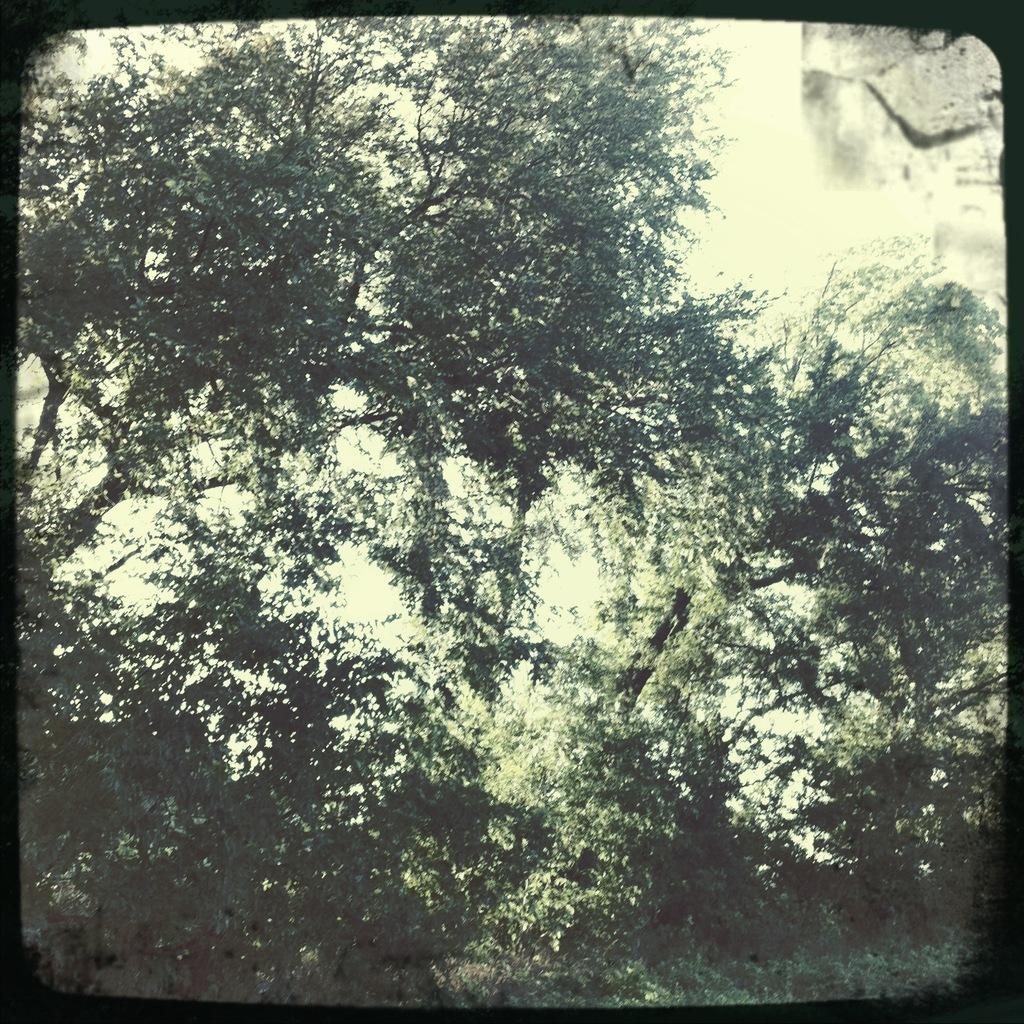What type of vegetation can be seen in the image? There are trees in the image. What part of the natural environment is visible in the image? The sky is visible in the background of the image. What type of treatment is being administered to the coach in the image? There is no coach or treatment present in the image; it features trees and the sky. 